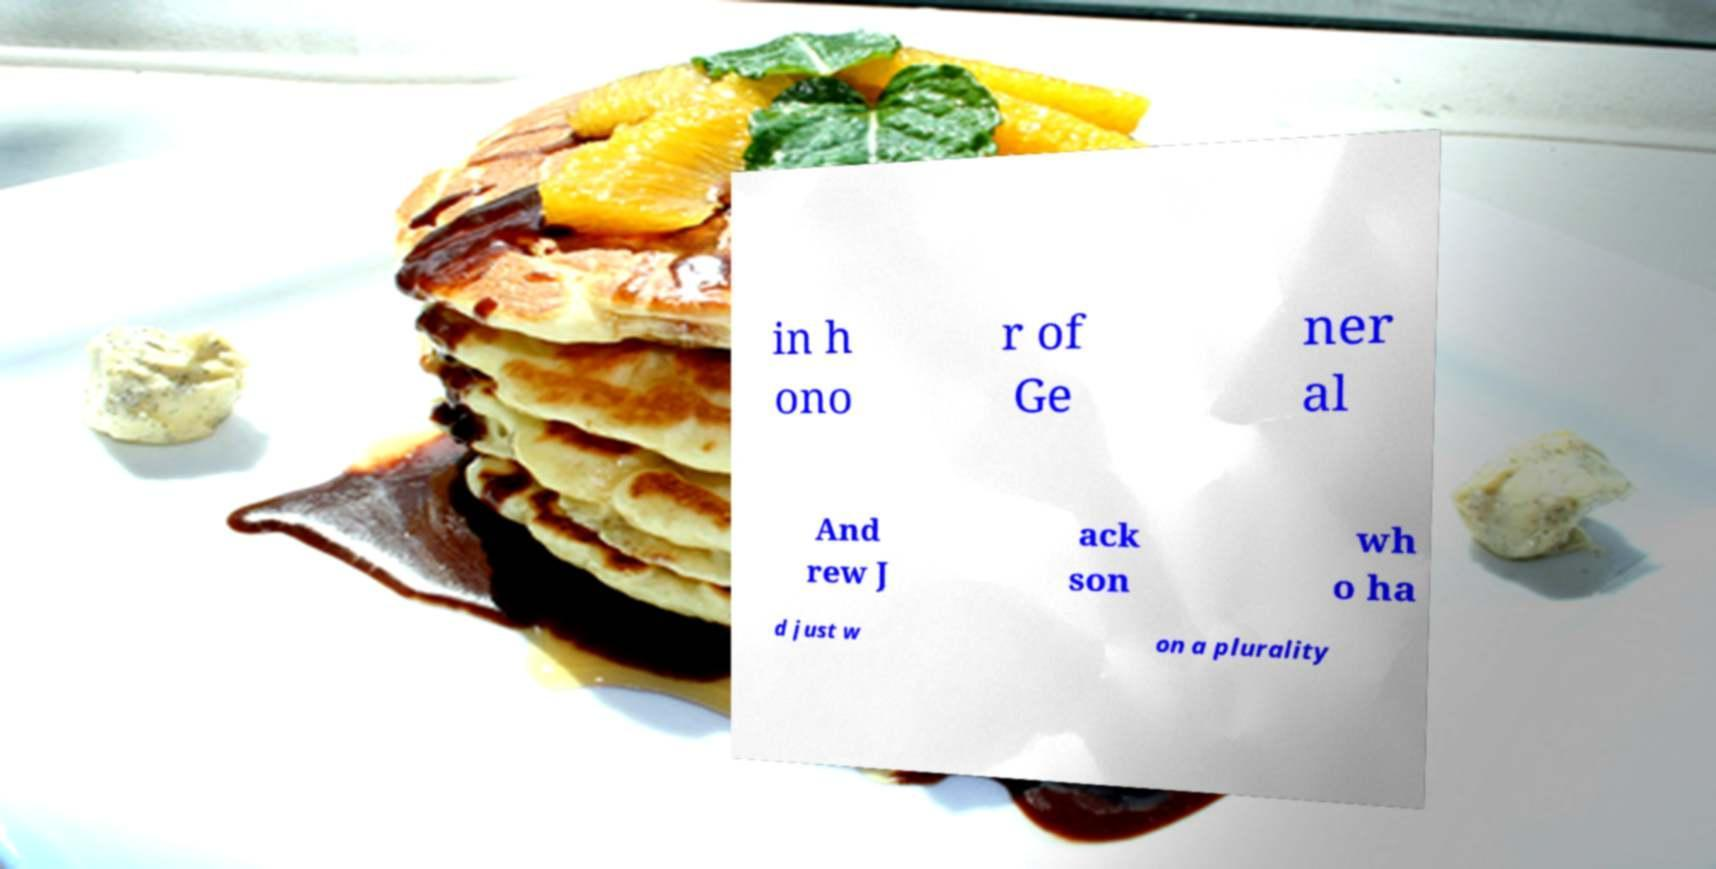What messages or text are displayed in this image? I need them in a readable, typed format. in h ono r of Ge ner al And rew J ack son wh o ha d just w on a plurality 